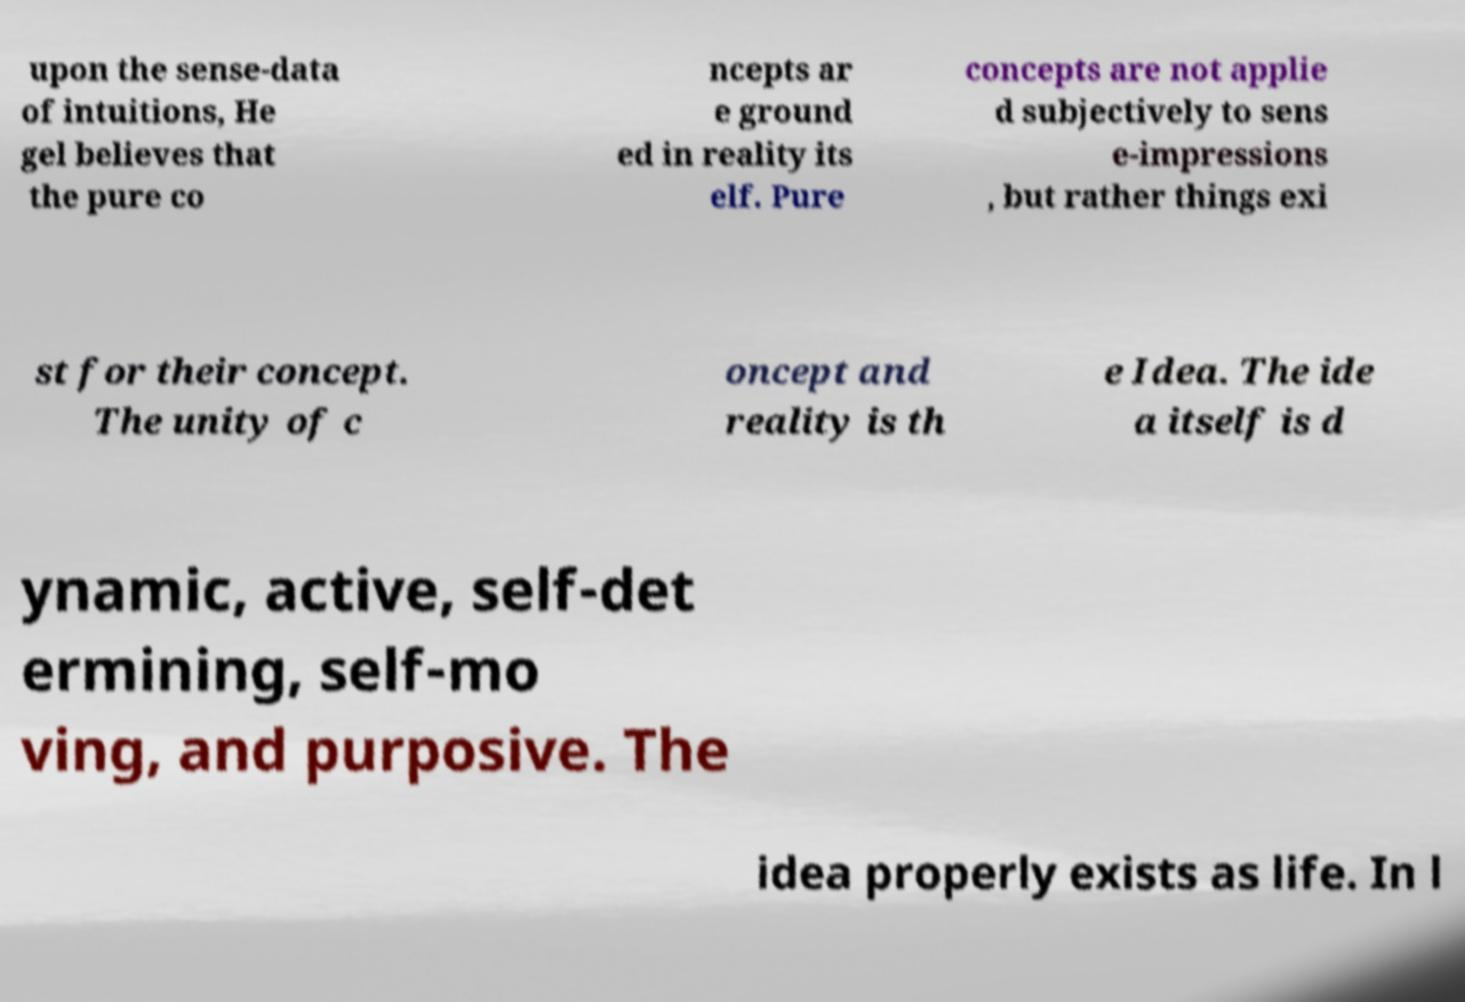Could you extract and type out the text from this image? upon the sense-data of intuitions, He gel believes that the pure co ncepts ar e ground ed in reality its elf. Pure concepts are not applie d subjectively to sens e-impressions , but rather things exi st for their concept. The unity of c oncept and reality is th e Idea. The ide a itself is d ynamic, active, self-det ermining, self-mo ving, and purposive. The idea properly exists as life. In l 